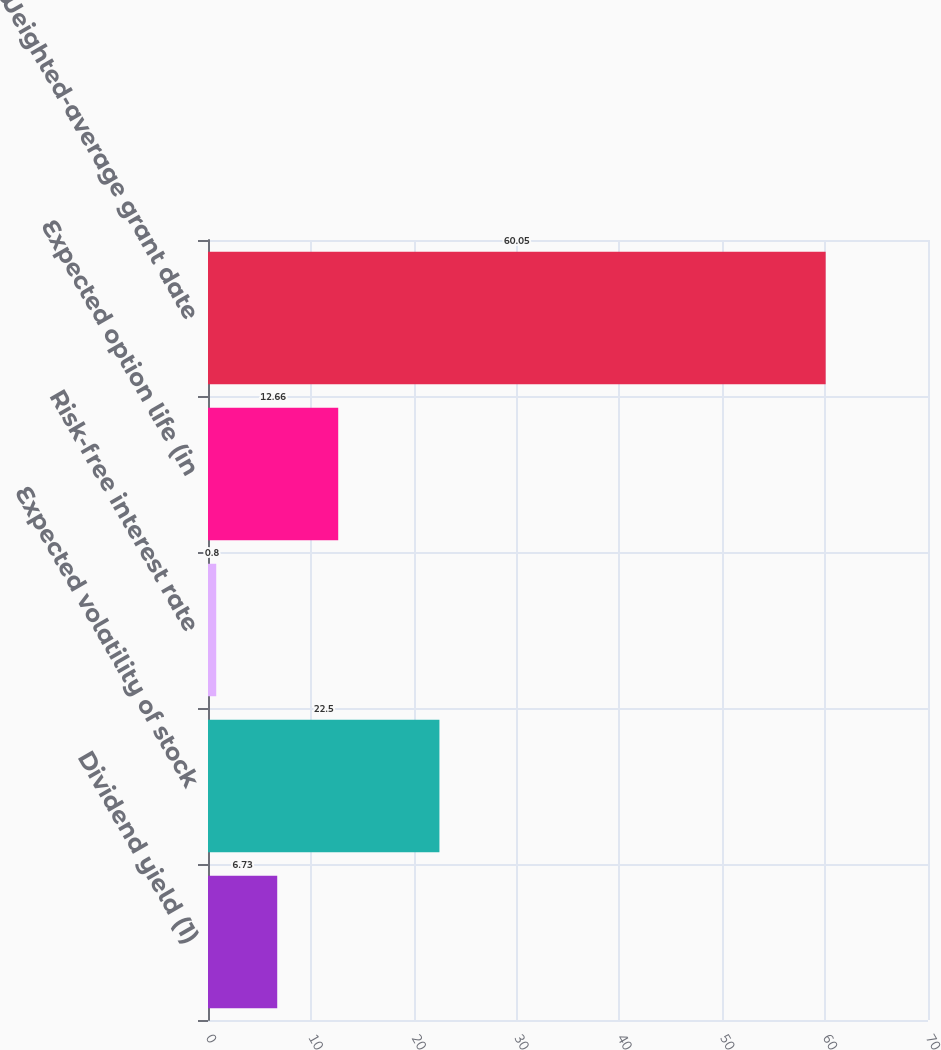Convert chart to OTSL. <chart><loc_0><loc_0><loc_500><loc_500><bar_chart><fcel>Dividend yield (1)<fcel>Expected volatility of stock<fcel>Risk-free interest rate<fcel>Expected option life (in<fcel>Weighted-average grant date<nl><fcel>6.73<fcel>22.5<fcel>0.8<fcel>12.66<fcel>60.05<nl></chart> 